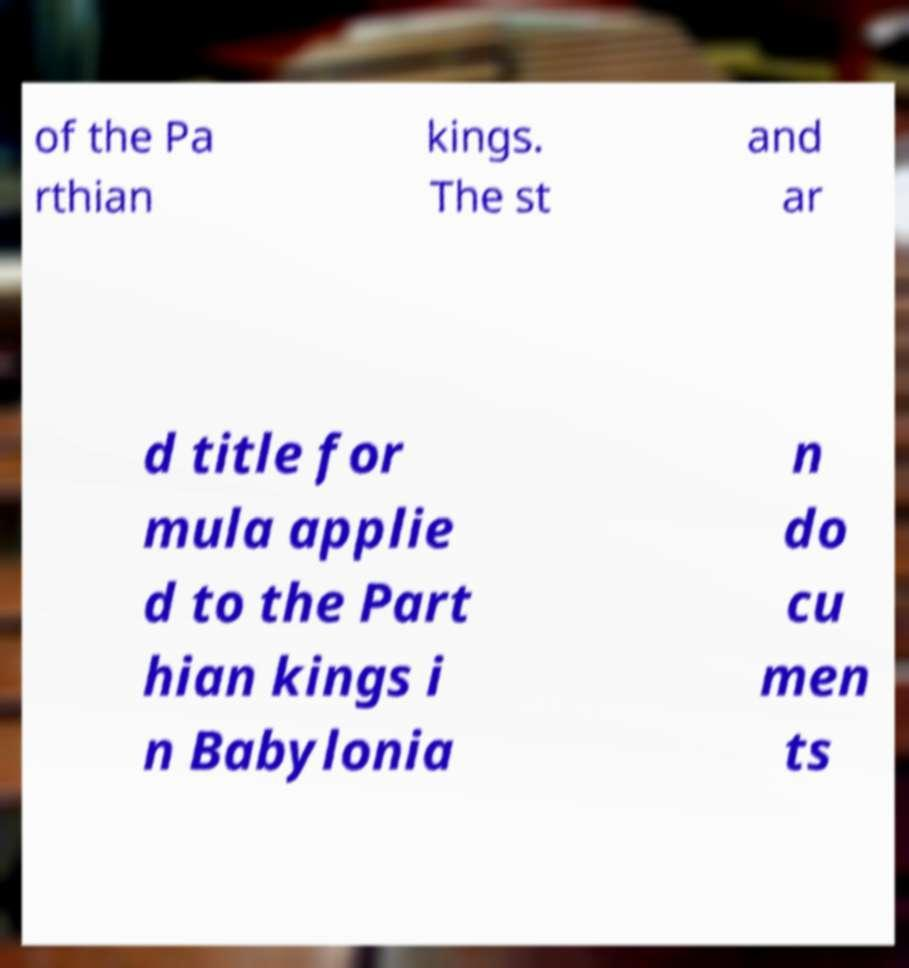Could you extract and type out the text from this image? of the Pa rthian kings. The st and ar d title for mula applie d to the Part hian kings i n Babylonia n do cu men ts 